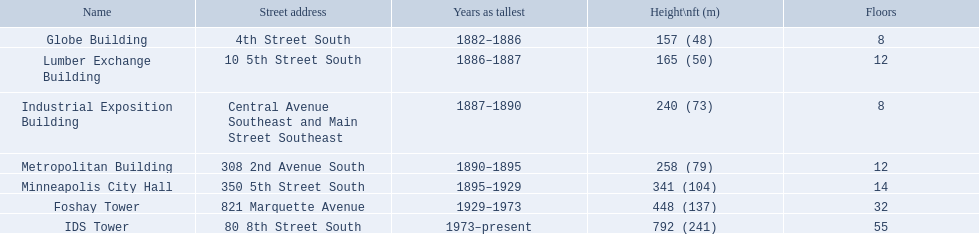What are the heights of the buildings? 157 (48), 165 (50), 240 (73), 258 (79), 341 (104), 448 (137), 792 (241). Write the full table. {'header': ['Name', 'Street address', 'Years as tallest', 'Height\\nft (m)', 'Floors'], 'rows': [['Globe Building', '4th Street South', '1882–1886', '157 (48)', '8'], ['Lumber Exchange Building', '10 5th Street South', '1886–1887', '165 (50)', '12'], ['Industrial Exposition Building', 'Central Avenue Southeast and Main Street Southeast', '1887–1890', '240 (73)', '8'], ['Metropolitan Building', '308 2nd Avenue South', '1890–1895', '258 (79)', '12'], ['Minneapolis City Hall', '350 5th Street South', '1895–1929', '341 (104)', '14'], ['Foshay Tower', '821 Marquette Avenue', '1929–1973', '448 (137)', '32'], ['IDS Tower', '80 8th Street South', '1973–present', '792 (241)', '55']]} What building is 240 ft tall? Industrial Exposition Building. How many floors does the globe building have? 8. Which building has 14 floors? Minneapolis City Hall. The lumber exchange building has the same number of floors as which building? Metropolitan Building. In which years was 240 feet deemed as a significant height? 1887–1890. Which structure possessed this distinction? Industrial Exposition Building. What are the most towering constructions in minneapolis? Globe Building, Lumber Exchange Building, Industrial Exposition Building, Metropolitan Building, Minneapolis City Hall, Foshay Tower, IDS Tower. Which of them have 8 floors? Globe Building, Industrial Exposition Building. Among them, which one measures 240 ft in height? Industrial Exposition Building. 